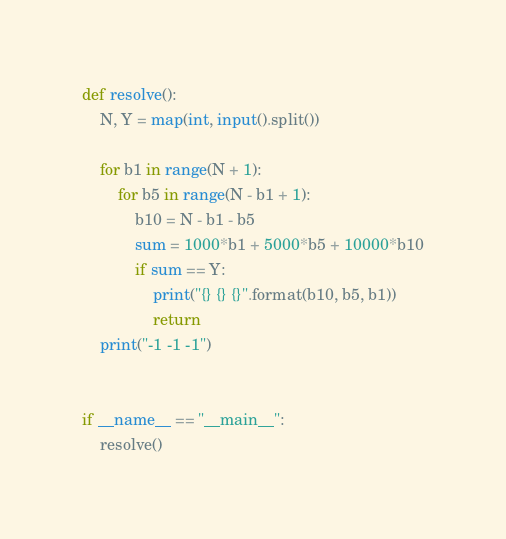Convert code to text. <code><loc_0><loc_0><loc_500><loc_500><_Python_>def resolve():
    N, Y = map(int, input().split())

    for b1 in range(N + 1):
        for b5 in range(N - b1 + 1):
            b10 = N - b1 - b5
            sum = 1000*b1 + 5000*b5 + 10000*b10
            if sum == Y:
                print("{} {} {}".format(b10, b5, b1))
                return
    print("-1 -1 -1")


if __name__ == "__main__":
    resolve()
</code> 